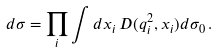Convert formula to latex. <formula><loc_0><loc_0><loc_500><loc_500>d \sigma = \prod _ { i } \int d x _ { i } \, D ( { q ^ { 2 } _ { i } } , x _ { i } ) d \sigma _ { 0 } \, .</formula> 